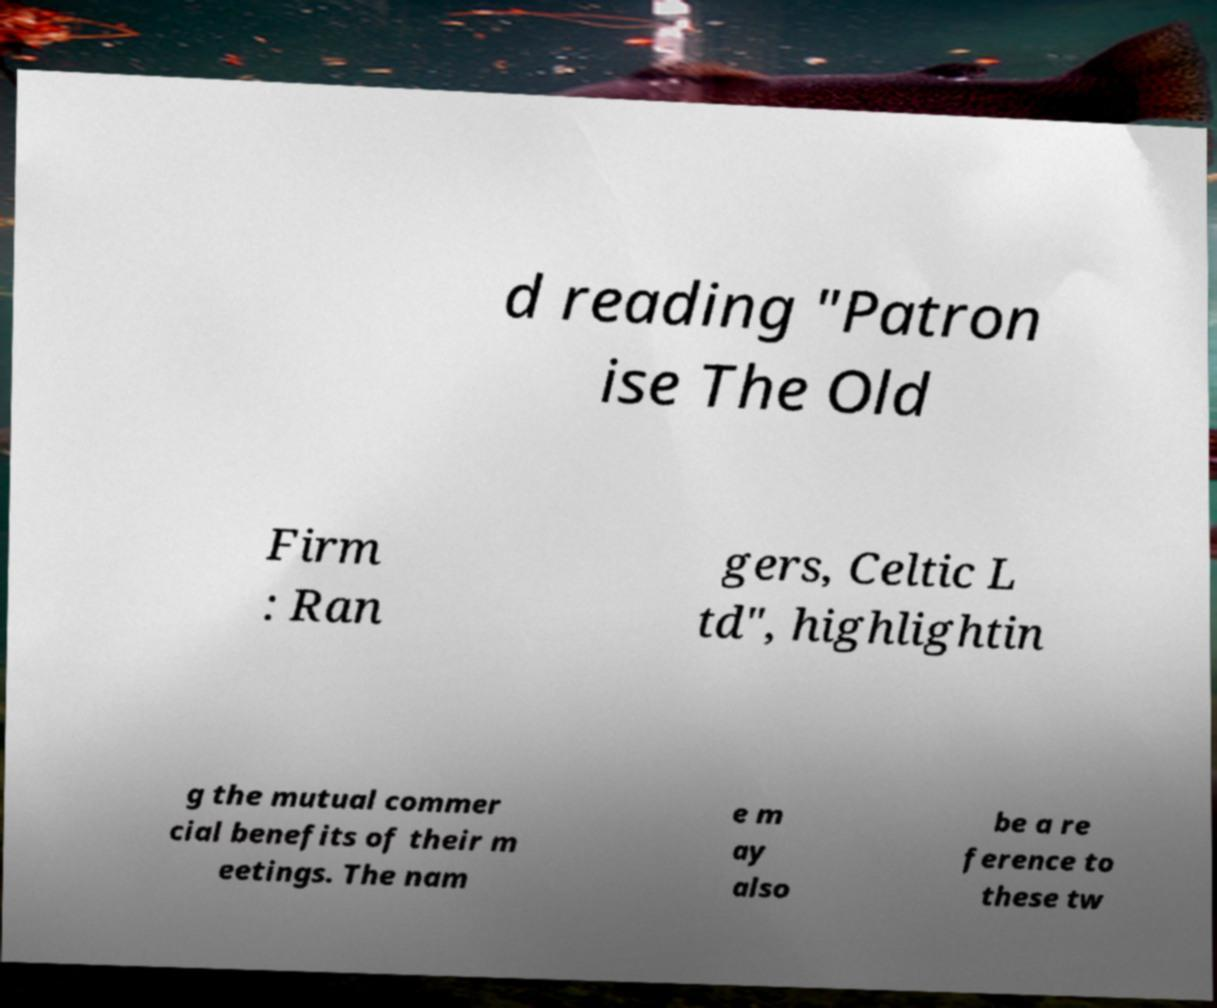For documentation purposes, I need the text within this image transcribed. Could you provide that? d reading "Patron ise The Old Firm : Ran gers, Celtic L td", highlightin g the mutual commer cial benefits of their m eetings. The nam e m ay also be a re ference to these tw 